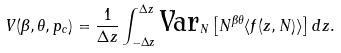Convert formula to latex. <formula><loc_0><loc_0><loc_500><loc_500>V ( \beta , \theta , p _ { c } ) = \frac { 1 } { \Delta z } \int ^ { \Delta z } _ { - \Delta z } \text {Var} _ { N } \left [ N ^ { \beta \theta } \langle f ( z , N ) \rangle \right ] d z .</formula> 